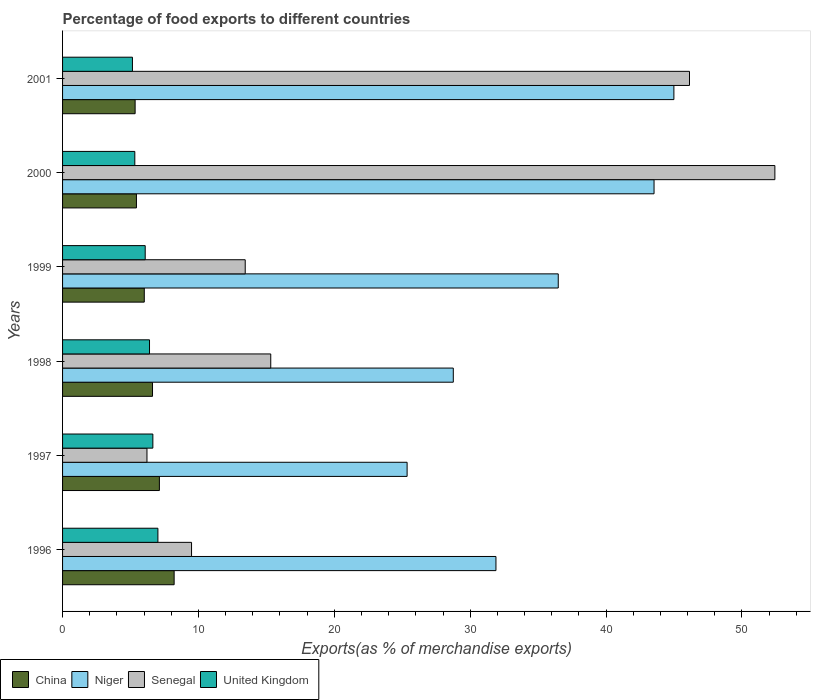How many groups of bars are there?
Provide a short and direct response. 6. Are the number of bars per tick equal to the number of legend labels?
Offer a terse response. Yes. Are the number of bars on each tick of the Y-axis equal?
Your response must be concise. Yes. What is the label of the 5th group of bars from the top?
Provide a short and direct response. 1997. In how many cases, is the number of bars for a given year not equal to the number of legend labels?
Offer a terse response. 0. What is the percentage of exports to different countries in Senegal in 1997?
Keep it short and to the point. 6.21. Across all years, what is the maximum percentage of exports to different countries in China?
Make the answer very short. 8.21. Across all years, what is the minimum percentage of exports to different countries in China?
Ensure brevity in your answer.  5.34. In which year was the percentage of exports to different countries in China minimum?
Your answer should be very brief. 2001. What is the total percentage of exports to different countries in Niger in the graph?
Keep it short and to the point. 211.01. What is the difference between the percentage of exports to different countries in United Kingdom in 1999 and that in 2001?
Ensure brevity in your answer.  0.94. What is the difference between the percentage of exports to different countries in China in 1998 and the percentage of exports to different countries in United Kingdom in 1999?
Your answer should be very brief. 0.54. What is the average percentage of exports to different countries in China per year?
Your response must be concise. 6.46. In the year 1998, what is the difference between the percentage of exports to different countries in Senegal and percentage of exports to different countries in Niger?
Ensure brevity in your answer.  -13.44. In how many years, is the percentage of exports to different countries in Niger greater than 22 %?
Your response must be concise. 6. What is the ratio of the percentage of exports to different countries in Niger in 1998 to that in 2001?
Offer a terse response. 0.64. Is the difference between the percentage of exports to different countries in Senegal in 1998 and 1999 greater than the difference between the percentage of exports to different countries in Niger in 1998 and 1999?
Ensure brevity in your answer.  Yes. What is the difference between the highest and the second highest percentage of exports to different countries in Senegal?
Keep it short and to the point. 6.28. What is the difference between the highest and the lowest percentage of exports to different countries in Senegal?
Provide a succinct answer. 46.21. Is the sum of the percentage of exports to different countries in China in 1996 and 1998 greater than the maximum percentage of exports to different countries in Niger across all years?
Offer a very short reply. No. What does the 3rd bar from the top in 2000 represents?
Offer a very short reply. Niger. Is it the case that in every year, the sum of the percentage of exports to different countries in China and percentage of exports to different countries in Niger is greater than the percentage of exports to different countries in Senegal?
Your answer should be compact. No. How many bars are there?
Provide a short and direct response. 24. How many years are there in the graph?
Give a very brief answer. 6. What is the difference between two consecutive major ticks on the X-axis?
Give a very brief answer. 10. Does the graph contain grids?
Your response must be concise. No. Where does the legend appear in the graph?
Your answer should be compact. Bottom left. How are the legend labels stacked?
Ensure brevity in your answer.  Horizontal. What is the title of the graph?
Your answer should be very brief. Percentage of food exports to different countries. Does "High income: OECD" appear as one of the legend labels in the graph?
Your response must be concise. No. What is the label or title of the X-axis?
Ensure brevity in your answer.  Exports(as % of merchandise exports). What is the label or title of the Y-axis?
Provide a short and direct response. Years. What is the Exports(as % of merchandise exports) of China in 1996?
Ensure brevity in your answer.  8.21. What is the Exports(as % of merchandise exports) in Niger in 1996?
Your answer should be very brief. 31.9. What is the Exports(as % of merchandise exports) of Senegal in 1996?
Offer a terse response. 9.49. What is the Exports(as % of merchandise exports) of United Kingdom in 1996?
Keep it short and to the point. 7.02. What is the Exports(as % of merchandise exports) in China in 1997?
Keep it short and to the point. 7.13. What is the Exports(as % of merchandise exports) of Niger in 1997?
Your answer should be very brief. 25.36. What is the Exports(as % of merchandise exports) in Senegal in 1997?
Offer a very short reply. 6.21. What is the Exports(as % of merchandise exports) of United Kingdom in 1997?
Give a very brief answer. 6.64. What is the Exports(as % of merchandise exports) in China in 1998?
Offer a very short reply. 6.62. What is the Exports(as % of merchandise exports) in Niger in 1998?
Your response must be concise. 28.76. What is the Exports(as % of merchandise exports) in Senegal in 1998?
Your answer should be compact. 15.32. What is the Exports(as % of merchandise exports) in United Kingdom in 1998?
Ensure brevity in your answer.  6.4. What is the Exports(as % of merchandise exports) in China in 1999?
Make the answer very short. 6.01. What is the Exports(as % of merchandise exports) of Niger in 1999?
Ensure brevity in your answer.  36.48. What is the Exports(as % of merchandise exports) in Senegal in 1999?
Keep it short and to the point. 13.44. What is the Exports(as % of merchandise exports) of United Kingdom in 1999?
Offer a terse response. 6.08. What is the Exports(as % of merchandise exports) of China in 2000?
Ensure brevity in your answer.  5.44. What is the Exports(as % of merchandise exports) in Niger in 2000?
Keep it short and to the point. 43.53. What is the Exports(as % of merchandise exports) in Senegal in 2000?
Make the answer very short. 52.42. What is the Exports(as % of merchandise exports) in United Kingdom in 2000?
Your answer should be very brief. 5.32. What is the Exports(as % of merchandise exports) of China in 2001?
Keep it short and to the point. 5.34. What is the Exports(as % of merchandise exports) in Niger in 2001?
Make the answer very short. 44.99. What is the Exports(as % of merchandise exports) of Senegal in 2001?
Your answer should be compact. 46.14. What is the Exports(as % of merchandise exports) of United Kingdom in 2001?
Make the answer very short. 5.14. Across all years, what is the maximum Exports(as % of merchandise exports) in China?
Your response must be concise. 8.21. Across all years, what is the maximum Exports(as % of merchandise exports) in Niger?
Offer a terse response. 44.99. Across all years, what is the maximum Exports(as % of merchandise exports) of Senegal?
Offer a terse response. 52.42. Across all years, what is the maximum Exports(as % of merchandise exports) in United Kingdom?
Your answer should be very brief. 7.02. Across all years, what is the minimum Exports(as % of merchandise exports) of China?
Ensure brevity in your answer.  5.34. Across all years, what is the minimum Exports(as % of merchandise exports) in Niger?
Your response must be concise. 25.36. Across all years, what is the minimum Exports(as % of merchandise exports) of Senegal?
Offer a terse response. 6.21. Across all years, what is the minimum Exports(as % of merchandise exports) of United Kingdom?
Make the answer very short. 5.14. What is the total Exports(as % of merchandise exports) in China in the graph?
Your answer should be compact. 38.75. What is the total Exports(as % of merchandise exports) in Niger in the graph?
Provide a succinct answer. 211.01. What is the total Exports(as % of merchandise exports) in Senegal in the graph?
Your answer should be compact. 143.03. What is the total Exports(as % of merchandise exports) of United Kingdom in the graph?
Your response must be concise. 36.6. What is the difference between the Exports(as % of merchandise exports) in China in 1996 and that in 1997?
Your response must be concise. 1.09. What is the difference between the Exports(as % of merchandise exports) of Niger in 1996 and that in 1997?
Provide a short and direct response. 6.54. What is the difference between the Exports(as % of merchandise exports) in Senegal in 1996 and that in 1997?
Provide a short and direct response. 3.28. What is the difference between the Exports(as % of merchandise exports) of United Kingdom in 1996 and that in 1997?
Ensure brevity in your answer.  0.37. What is the difference between the Exports(as % of merchandise exports) of China in 1996 and that in 1998?
Keep it short and to the point. 1.59. What is the difference between the Exports(as % of merchandise exports) of Niger in 1996 and that in 1998?
Provide a short and direct response. 3.14. What is the difference between the Exports(as % of merchandise exports) of Senegal in 1996 and that in 1998?
Provide a short and direct response. -5.83. What is the difference between the Exports(as % of merchandise exports) of United Kingdom in 1996 and that in 1998?
Your answer should be compact. 0.62. What is the difference between the Exports(as % of merchandise exports) in China in 1996 and that in 1999?
Your response must be concise. 2.2. What is the difference between the Exports(as % of merchandise exports) of Niger in 1996 and that in 1999?
Make the answer very short. -4.59. What is the difference between the Exports(as % of merchandise exports) in Senegal in 1996 and that in 1999?
Your response must be concise. -3.95. What is the difference between the Exports(as % of merchandise exports) in United Kingdom in 1996 and that in 1999?
Provide a short and direct response. 0.93. What is the difference between the Exports(as % of merchandise exports) of China in 1996 and that in 2000?
Your response must be concise. 2.77. What is the difference between the Exports(as % of merchandise exports) in Niger in 1996 and that in 2000?
Offer a terse response. -11.63. What is the difference between the Exports(as % of merchandise exports) of Senegal in 1996 and that in 2000?
Offer a very short reply. -42.93. What is the difference between the Exports(as % of merchandise exports) in United Kingdom in 1996 and that in 2000?
Your answer should be compact. 1.7. What is the difference between the Exports(as % of merchandise exports) in China in 1996 and that in 2001?
Make the answer very short. 2.87. What is the difference between the Exports(as % of merchandise exports) of Niger in 1996 and that in 2001?
Keep it short and to the point. -13.1. What is the difference between the Exports(as % of merchandise exports) in Senegal in 1996 and that in 2001?
Offer a very short reply. -36.65. What is the difference between the Exports(as % of merchandise exports) of United Kingdom in 1996 and that in 2001?
Provide a short and direct response. 1.87. What is the difference between the Exports(as % of merchandise exports) of China in 1997 and that in 1998?
Keep it short and to the point. 0.51. What is the difference between the Exports(as % of merchandise exports) in Niger in 1997 and that in 1998?
Provide a short and direct response. -3.4. What is the difference between the Exports(as % of merchandise exports) in Senegal in 1997 and that in 1998?
Your answer should be compact. -9.11. What is the difference between the Exports(as % of merchandise exports) of United Kingdom in 1997 and that in 1998?
Give a very brief answer. 0.25. What is the difference between the Exports(as % of merchandise exports) in China in 1997 and that in 1999?
Ensure brevity in your answer.  1.11. What is the difference between the Exports(as % of merchandise exports) in Niger in 1997 and that in 1999?
Provide a succinct answer. -11.12. What is the difference between the Exports(as % of merchandise exports) in Senegal in 1997 and that in 1999?
Your answer should be compact. -7.23. What is the difference between the Exports(as % of merchandise exports) in United Kingdom in 1997 and that in 1999?
Give a very brief answer. 0.56. What is the difference between the Exports(as % of merchandise exports) of China in 1997 and that in 2000?
Your answer should be compact. 1.69. What is the difference between the Exports(as % of merchandise exports) in Niger in 1997 and that in 2000?
Your response must be concise. -18.17. What is the difference between the Exports(as % of merchandise exports) in Senegal in 1997 and that in 2000?
Provide a short and direct response. -46.21. What is the difference between the Exports(as % of merchandise exports) of United Kingdom in 1997 and that in 2000?
Provide a short and direct response. 1.33. What is the difference between the Exports(as % of merchandise exports) of China in 1997 and that in 2001?
Your answer should be very brief. 1.79. What is the difference between the Exports(as % of merchandise exports) in Niger in 1997 and that in 2001?
Keep it short and to the point. -19.63. What is the difference between the Exports(as % of merchandise exports) of Senegal in 1997 and that in 2001?
Your answer should be compact. -39.93. What is the difference between the Exports(as % of merchandise exports) in United Kingdom in 1997 and that in 2001?
Provide a short and direct response. 1.5. What is the difference between the Exports(as % of merchandise exports) in China in 1998 and that in 1999?
Offer a terse response. 0.61. What is the difference between the Exports(as % of merchandise exports) of Niger in 1998 and that in 1999?
Provide a succinct answer. -7.72. What is the difference between the Exports(as % of merchandise exports) of Senegal in 1998 and that in 1999?
Your answer should be very brief. 1.88. What is the difference between the Exports(as % of merchandise exports) in United Kingdom in 1998 and that in 1999?
Offer a very short reply. 0.32. What is the difference between the Exports(as % of merchandise exports) of China in 1998 and that in 2000?
Ensure brevity in your answer.  1.18. What is the difference between the Exports(as % of merchandise exports) in Niger in 1998 and that in 2000?
Your answer should be very brief. -14.77. What is the difference between the Exports(as % of merchandise exports) in Senegal in 1998 and that in 2000?
Make the answer very short. -37.1. What is the difference between the Exports(as % of merchandise exports) in United Kingdom in 1998 and that in 2000?
Your answer should be compact. 1.08. What is the difference between the Exports(as % of merchandise exports) in China in 1998 and that in 2001?
Provide a succinct answer. 1.28. What is the difference between the Exports(as % of merchandise exports) in Niger in 1998 and that in 2001?
Your response must be concise. -16.24. What is the difference between the Exports(as % of merchandise exports) of Senegal in 1998 and that in 2001?
Your response must be concise. -30.82. What is the difference between the Exports(as % of merchandise exports) of United Kingdom in 1998 and that in 2001?
Your answer should be compact. 1.26. What is the difference between the Exports(as % of merchandise exports) of China in 1999 and that in 2000?
Offer a very short reply. 0.58. What is the difference between the Exports(as % of merchandise exports) of Niger in 1999 and that in 2000?
Keep it short and to the point. -7.05. What is the difference between the Exports(as % of merchandise exports) in Senegal in 1999 and that in 2000?
Keep it short and to the point. -38.98. What is the difference between the Exports(as % of merchandise exports) in United Kingdom in 1999 and that in 2000?
Ensure brevity in your answer.  0.77. What is the difference between the Exports(as % of merchandise exports) in China in 1999 and that in 2001?
Provide a succinct answer. 0.67. What is the difference between the Exports(as % of merchandise exports) in Niger in 1999 and that in 2001?
Offer a very short reply. -8.51. What is the difference between the Exports(as % of merchandise exports) of Senegal in 1999 and that in 2001?
Provide a succinct answer. -32.7. What is the difference between the Exports(as % of merchandise exports) of United Kingdom in 1999 and that in 2001?
Keep it short and to the point. 0.94. What is the difference between the Exports(as % of merchandise exports) of China in 2000 and that in 2001?
Give a very brief answer. 0.1. What is the difference between the Exports(as % of merchandise exports) of Niger in 2000 and that in 2001?
Provide a succinct answer. -1.46. What is the difference between the Exports(as % of merchandise exports) of Senegal in 2000 and that in 2001?
Make the answer very short. 6.28. What is the difference between the Exports(as % of merchandise exports) of United Kingdom in 2000 and that in 2001?
Keep it short and to the point. 0.17. What is the difference between the Exports(as % of merchandise exports) in China in 1996 and the Exports(as % of merchandise exports) in Niger in 1997?
Your answer should be very brief. -17.15. What is the difference between the Exports(as % of merchandise exports) in China in 1996 and the Exports(as % of merchandise exports) in Senegal in 1997?
Your response must be concise. 2. What is the difference between the Exports(as % of merchandise exports) of China in 1996 and the Exports(as % of merchandise exports) of United Kingdom in 1997?
Offer a very short reply. 1.57. What is the difference between the Exports(as % of merchandise exports) of Niger in 1996 and the Exports(as % of merchandise exports) of Senegal in 1997?
Ensure brevity in your answer.  25.68. What is the difference between the Exports(as % of merchandise exports) of Niger in 1996 and the Exports(as % of merchandise exports) of United Kingdom in 1997?
Make the answer very short. 25.25. What is the difference between the Exports(as % of merchandise exports) in Senegal in 1996 and the Exports(as % of merchandise exports) in United Kingdom in 1997?
Give a very brief answer. 2.85. What is the difference between the Exports(as % of merchandise exports) of China in 1996 and the Exports(as % of merchandise exports) of Niger in 1998?
Your response must be concise. -20.55. What is the difference between the Exports(as % of merchandise exports) in China in 1996 and the Exports(as % of merchandise exports) in Senegal in 1998?
Keep it short and to the point. -7.11. What is the difference between the Exports(as % of merchandise exports) in China in 1996 and the Exports(as % of merchandise exports) in United Kingdom in 1998?
Your answer should be very brief. 1.81. What is the difference between the Exports(as % of merchandise exports) of Niger in 1996 and the Exports(as % of merchandise exports) of Senegal in 1998?
Provide a succinct answer. 16.57. What is the difference between the Exports(as % of merchandise exports) of Niger in 1996 and the Exports(as % of merchandise exports) of United Kingdom in 1998?
Offer a terse response. 25.5. What is the difference between the Exports(as % of merchandise exports) of Senegal in 1996 and the Exports(as % of merchandise exports) of United Kingdom in 1998?
Your response must be concise. 3.09. What is the difference between the Exports(as % of merchandise exports) of China in 1996 and the Exports(as % of merchandise exports) of Niger in 1999?
Provide a short and direct response. -28.27. What is the difference between the Exports(as % of merchandise exports) in China in 1996 and the Exports(as % of merchandise exports) in Senegal in 1999?
Give a very brief answer. -5.23. What is the difference between the Exports(as % of merchandise exports) of China in 1996 and the Exports(as % of merchandise exports) of United Kingdom in 1999?
Offer a very short reply. 2.13. What is the difference between the Exports(as % of merchandise exports) in Niger in 1996 and the Exports(as % of merchandise exports) in Senegal in 1999?
Offer a terse response. 18.45. What is the difference between the Exports(as % of merchandise exports) of Niger in 1996 and the Exports(as % of merchandise exports) of United Kingdom in 1999?
Provide a succinct answer. 25.81. What is the difference between the Exports(as % of merchandise exports) in Senegal in 1996 and the Exports(as % of merchandise exports) in United Kingdom in 1999?
Your response must be concise. 3.41. What is the difference between the Exports(as % of merchandise exports) in China in 1996 and the Exports(as % of merchandise exports) in Niger in 2000?
Give a very brief answer. -35.32. What is the difference between the Exports(as % of merchandise exports) of China in 1996 and the Exports(as % of merchandise exports) of Senegal in 2000?
Your answer should be very brief. -44.21. What is the difference between the Exports(as % of merchandise exports) in China in 1996 and the Exports(as % of merchandise exports) in United Kingdom in 2000?
Your answer should be very brief. 2.89. What is the difference between the Exports(as % of merchandise exports) in Niger in 1996 and the Exports(as % of merchandise exports) in Senegal in 2000?
Your response must be concise. -20.53. What is the difference between the Exports(as % of merchandise exports) of Niger in 1996 and the Exports(as % of merchandise exports) of United Kingdom in 2000?
Give a very brief answer. 26.58. What is the difference between the Exports(as % of merchandise exports) in Senegal in 1996 and the Exports(as % of merchandise exports) in United Kingdom in 2000?
Ensure brevity in your answer.  4.18. What is the difference between the Exports(as % of merchandise exports) of China in 1996 and the Exports(as % of merchandise exports) of Niger in 2001?
Give a very brief answer. -36.78. What is the difference between the Exports(as % of merchandise exports) in China in 1996 and the Exports(as % of merchandise exports) in Senegal in 2001?
Your answer should be compact. -37.93. What is the difference between the Exports(as % of merchandise exports) in China in 1996 and the Exports(as % of merchandise exports) in United Kingdom in 2001?
Give a very brief answer. 3.07. What is the difference between the Exports(as % of merchandise exports) in Niger in 1996 and the Exports(as % of merchandise exports) in Senegal in 2001?
Give a very brief answer. -14.24. What is the difference between the Exports(as % of merchandise exports) in Niger in 1996 and the Exports(as % of merchandise exports) in United Kingdom in 2001?
Offer a very short reply. 26.75. What is the difference between the Exports(as % of merchandise exports) in Senegal in 1996 and the Exports(as % of merchandise exports) in United Kingdom in 2001?
Make the answer very short. 4.35. What is the difference between the Exports(as % of merchandise exports) of China in 1997 and the Exports(as % of merchandise exports) of Niger in 1998?
Make the answer very short. -21.63. What is the difference between the Exports(as % of merchandise exports) of China in 1997 and the Exports(as % of merchandise exports) of Senegal in 1998?
Provide a succinct answer. -8.2. What is the difference between the Exports(as % of merchandise exports) in China in 1997 and the Exports(as % of merchandise exports) in United Kingdom in 1998?
Give a very brief answer. 0.73. What is the difference between the Exports(as % of merchandise exports) of Niger in 1997 and the Exports(as % of merchandise exports) of Senegal in 1998?
Offer a very short reply. 10.04. What is the difference between the Exports(as % of merchandise exports) of Niger in 1997 and the Exports(as % of merchandise exports) of United Kingdom in 1998?
Your response must be concise. 18.96. What is the difference between the Exports(as % of merchandise exports) in Senegal in 1997 and the Exports(as % of merchandise exports) in United Kingdom in 1998?
Give a very brief answer. -0.19. What is the difference between the Exports(as % of merchandise exports) in China in 1997 and the Exports(as % of merchandise exports) in Niger in 1999?
Give a very brief answer. -29.36. What is the difference between the Exports(as % of merchandise exports) in China in 1997 and the Exports(as % of merchandise exports) in Senegal in 1999?
Your response must be concise. -6.32. What is the difference between the Exports(as % of merchandise exports) of China in 1997 and the Exports(as % of merchandise exports) of United Kingdom in 1999?
Your answer should be compact. 1.04. What is the difference between the Exports(as % of merchandise exports) of Niger in 1997 and the Exports(as % of merchandise exports) of Senegal in 1999?
Your answer should be very brief. 11.91. What is the difference between the Exports(as % of merchandise exports) in Niger in 1997 and the Exports(as % of merchandise exports) in United Kingdom in 1999?
Your response must be concise. 19.28. What is the difference between the Exports(as % of merchandise exports) in Senegal in 1997 and the Exports(as % of merchandise exports) in United Kingdom in 1999?
Ensure brevity in your answer.  0.13. What is the difference between the Exports(as % of merchandise exports) in China in 1997 and the Exports(as % of merchandise exports) in Niger in 2000?
Keep it short and to the point. -36.4. What is the difference between the Exports(as % of merchandise exports) in China in 1997 and the Exports(as % of merchandise exports) in Senegal in 2000?
Ensure brevity in your answer.  -45.3. What is the difference between the Exports(as % of merchandise exports) of China in 1997 and the Exports(as % of merchandise exports) of United Kingdom in 2000?
Your answer should be very brief. 1.81. What is the difference between the Exports(as % of merchandise exports) in Niger in 1997 and the Exports(as % of merchandise exports) in Senegal in 2000?
Provide a short and direct response. -27.07. What is the difference between the Exports(as % of merchandise exports) in Niger in 1997 and the Exports(as % of merchandise exports) in United Kingdom in 2000?
Give a very brief answer. 20.04. What is the difference between the Exports(as % of merchandise exports) in Senegal in 1997 and the Exports(as % of merchandise exports) in United Kingdom in 2000?
Offer a terse response. 0.89. What is the difference between the Exports(as % of merchandise exports) of China in 1997 and the Exports(as % of merchandise exports) of Niger in 2001?
Give a very brief answer. -37.87. What is the difference between the Exports(as % of merchandise exports) in China in 1997 and the Exports(as % of merchandise exports) in Senegal in 2001?
Your response must be concise. -39.01. What is the difference between the Exports(as % of merchandise exports) of China in 1997 and the Exports(as % of merchandise exports) of United Kingdom in 2001?
Provide a succinct answer. 1.98. What is the difference between the Exports(as % of merchandise exports) of Niger in 1997 and the Exports(as % of merchandise exports) of Senegal in 2001?
Your answer should be very brief. -20.78. What is the difference between the Exports(as % of merchandise exports) of Niger in 1997 and the Exports(as % of merchandise exports) of United Kingdom in 2001?
Provide a succinct answer. 20.21. What is the difference between the Exports(as % of merchandise exports) in Senegal in 1997 and the Exports(as % of merchandise exports) in United Kingdom in 2001?
Make the answer very short. 1.07. What is the difference between the Exports(as % of merchandise exports) of China in 1998 and the Exports(as % of merchandise exports) of Niger in 1999?
Your response must be concise. -29.86. What is the difference between the Exports(as % of merchandise exports) of China in 1998 and the Exports(as % of merchandise exports) of Senegal in 1999?
Give a very brief answer. -6.82. What is the difference between the Exports(as % of merchandise exports) in China in 1998 and the Exports(as % of merchandise exports) in United Kingdom in 1999?
Provide a short and direct response. 0.54. What is the difference between the Exports(as % of merchandise exports) in Niger in 1998 and the Exports(as % of merchandise exports) in Senegal in 1999?
Keep it short and to the point. 15.31. What is the difference between the Exports(as % of merchandise exports) in Niger in 1998 and the Exports(as % of merchandise exports) in United Kingdom in 1999?
Your answer should be very brief. 22.67. What is the difference between the Exports(as % of merchandise exports) in Senegal in 1998 and the Exports(as % of merchandise exports) in United Kingdom in 1999?
Your answer should be very brief. 9.24. What is the difference between the Exports(as % of merchandise exports) in China in 1998 and the Exports(as % of merchandise exports) in Niger in 2000?
Your answer should be very brief. -36.91. What is the difference between the Exports(as % of merchandise exports) in China in 1998 and the Exports(as % of merchandise exports) in Senegal in 2000?
Provide a short and direct response. -45.8. What is the difference between the Exports(as % of merchandise exports) in China in 1998 and the Exports(as % of merchandise exports) in United Kingdom in 2000?
Give a very brief answer. 1.3. What is the difference between the Exports(as % of merchandise exports) of Niger in 1998 and the Exports(as % of merchandise exports) of Senegal in 2000?
Provide a short and direct response. -23.67. What is the difference between the Exports(as % of merchandise exports) in Niger in 1998 and the Exports(as % of merchandise exports) in United Kingdom in 2000?
Your response must be concise. 23.44. What is the difference between the Exports(as % of merchandise exports) in Senegal in 1998 and the Exports(as % of merchandise exports) in United Kingdom in 2000?
Ensure brevity in your answer.  10. What is the difference between the Exports(as % of merchandise exports) of China in 1998 and the Exports(as % of merchandise exports) of Niger in 2001?
Provide a short and direct response. -38.37. What is the difference between the Exports(as % of merchandise exports) of China in 1998 and the Exports(as % of merchandise exports) of Senegal in 2001?
Your answer should be compact. -39.52. What is the difference between the Exports(as % of merchandise exports) of China in 1998 and the Exports(as % of merchandise exports) of United Kingdom in 2001?
Your answer should be very brief. 1.48. What is the difference between the Exports(as % of merchandise exports) in Niger in 1998 and the Exports(as % of merchandise exports) in Senegal in 2001?
Offer a terse response. -17.38. What is the difference between the Exports(as % of merchandise exports) of Niger in 1998 and the Exports(as % of merchandise exports) of United Kingdom in 2001?
Your response must be concise. 23.61. What is the difference between the Exports(as % of merchandise exports) in Senegal in 1998 and the Exports(as % of merchandise exports) in United Kingdom in 2001?
Your answer should be very brief. 10.18. What is the difference between the Exports(as % of merchandise exports) of China in 1999 and the Exports(as % of merchandise exports) of Niger in 2000?
Your answer should be very brief. -37.52. What is the difference between the Exports(as % of merchandise exports) of China in 1999 and the Exports(as % of merchandise exports) of Senegal in 2000?
Make the answer very short. -46.41. What is the difference between the Exports(as % of merchandise exports) in China in 1999 and the Exports(as % of merchandise exports) in United Kingdom in 2000?
Offer a very short reply. 0.7. What is the difference between the Exports(as % of merchandise exports) in Niger in 1999 and the Exports(as % of merchandise exports) in Senegal in 2000?
Offer a terse response. -15.94. What is the difference between the Exports(as % of merchandise exports) in Niger in 1999 and the Exports(as % of merchandise exports) in United Kingdom in 2000?
Your answer should be very brief. 31.16. What is the difference between the Exports(as % of merchandise exports) in Senegal in 1999 and the Exports(as % of merchandise exports) in United Kingdom in 2000?
Provide a short and direct response. 8.13. What is the difference between the Exports(as % of merchandise exports) in China in 1999 and the Exports(as % of merchandise exports) in Niger in 2001?
Your response must be concise. -38.98. What is the difference between the Exports(as % of merchandise exports) in China in 1999 and the Exports(as % of merchandise exports) in Senegal in 2001?
Your answer should be compact. -40.13. What is the difference between the Exports(as % of merchandise exports) in China in 1999 and the Exports(as % of merchandise exports) in United Kingdom in 2001?
Give a very brief answer. 0.87. What is the difference between the Exports(as % of merchandise exports) in Niger in 1999 and the Exports(as % of merchandise exports) in Senegal in 2001?
Provide a succinct answer. -9.66. What is the difference between the Exports(as % of merchandise exports) of Niger in 1999 and the Exports(as % of merchandise exports) of United Kingdom in 2001?
Offer a terse response. 31.34. What is the difference between the Exports(as % of merchandise exports) in Senegal in 1999 and the Exports(as % of merchandise exports) in United Kingdom in 2001?
Make the answer very short. 8.3. What is the difference between the Exports(as % of merchandise exports) in China in 2000 and the Exports(as % of merchandise exports) in Niger in 2001?
Give a very brief answer. -39.55. What is the difference between the Exports(as % of merchandise exports) in China in 2000 and the Exports(as % of merchandise exports) in Senegal in 2001?
Provide a succinct answer. -40.7. What is the difference between the Exports(as % of merchandise exports) in China in 2000 and the Exports(as % of merchandise exports) in United Kingdom in 2001?
Provide a short and direct response. 0.29. What is the difference between the Exports(as % of merchandise exports) of Niger in 2000 and the Exports(as % of merchandise exports) of Senegal in 2001?
Give a very brief answer. -2.61. What is the difference between the Exports(as % of merchandise exports) of Niger in 2000 and the Exports(as % of merchandise exports) of United Kingdom in 2001?
Your answer should be very brief. 38.39. What is the difference between the Exports(as % of merchandise exports) of Senegal in 2000 and the Exports(as % of merchandise exports) of United Kingdom in 2001?
Provide a succinct answer. 47.28. What is the average Exports(as % of merchandise exports) of China per year?
Offer a very short reply. 6.46. What is the average Exports(as % of merchandise exports) of Niger per year?
Offer a terse response. 35.17. What is the average Exports(as % of merchandise exports) in Senegal per year?
Give a very brief answer. 23.84. What is the average Exports(as % of merchandise exports) in United Kingdom per year?
Give a very brief answer. 6.1. In the year 1996, what is the difference between the Exports(as % of merchandise exports) in China and Exports(as % of merchandise exports) in Niger?
Your answer should be compact. -23.68. In the year 1996, what is the difference between the Exports(as % of merchandise exports) in China and Exports(as % of merchandise exports) in Senegal?
Give a very brief answer. -1.28. In the year 1996, what is the difference between the Exports(as % of merchandise exports) of China and Exports(as % of merchandise exports) of United Kingdom?
Your response must be concise. 1.2. In the year 1996, what is the difference between the Exports(as % of merchandise exports) in Niger and Exports(as % of merchandise exports) in Senegal?
Ensure brevity in your answer.  22.4. In the year 1996, what is the difference between the Exports(as % of merchandise exports) in Niger and Exports(as % of merchandise exports) in United Kingdom?
Keep it short and to the point. 24.88. In the year 1996, what is the difference between the Exports(as % of merchandise exports) in Senegal and Exports(as % of merchandise exports) in United Kingdom?
Keep it short and to the point. 2.48. In the year 1997, what is the difference between the Exports(as % of merchandise exports) in China and Exports(as % of merchandise exports) in Niger?
Your answer should be compact. -18.23. In the year 1997, what is the difference between the Exports(as % of merchandise exports) in China and Exports(as % of merchandise exports) in Senegal?
Give a very brief answer. 0.91. In the year 1997, what is the difference between the Exports(as % of merchandise exports) of China and Exports(as % of merchandise exports) of United Kingdom?
Provide a succinct answer. 0.48. In the year 1997, what is the difference between the Exports(as % of merchandise exports) of Niger and Exports(as % of merchandise exports) of Senegal?
Provide a succinct answer. 19.15. In the year 1997, what is the difference between the Exports(as % of merchandise exports) of Niger and Exports(as % of merchandise exports) of United Kingdom?
Provide a succinct answer. 18.71. In the year 1997, what is the difference between the Exports(as % of merchandise exports) of Senegal and Exports(as % of merchandise exports) of United Kingdom?
Give a very brief answer. -0.43. In the year 1998, what is the difference between the Exports(as % of merchandise exports) in China and Exports(as % of merchandise exports) in Niger?
Give a very brief answer. -22.14. In the year 1998, what is the difference between the Exports(as % of merchandise exports) in China and Exports(as % of merchandise exports) in Senegal?
Your response must be concise. -8.7. In the year 1998, what is the difference between the Exports(as % of merchandise exports) of China and Exports(as % of merchandise exports) of United Kingdom?
Make the answer very short. 0.22. In the year 1998, what is the difference between the Exports(as % of merchandise exports) in Niger and Exports(as % of merchandise exports) in Senegal?
Your answer should be compact. 13.44. In the year 1998, what is the difference between the Exports(as % of merchandise exports) in Niger and Exports(as % of merchandise exports) in United Kingdom?
Offer a terse response. 22.36. In the year 1998, what is the difference between the Exports(as % of merchandise exports) of Senegal and Exports(as % of merchandise exports) of United Kingdom?
Ensure brevity in your answer.  8.92. In the year 1999, what is the difference between the Exports(as % of merchandise exports) in China and Exports(as % of merchandise exports) in Niger?
Make the answer very short. -30.47. In the year 1999, what is the difference between the Exports(as % of merchandise exports) of China and Exports(as % of merchandise exports) of Senegal?
Offer a terse response. -7.43. In the year 1999, what is the difference between the Exports(as % of merchandise exports) in China and Exports(as % of merchandise exports) in United Kingdom?
Make the answer very short. -0.07. In the year 1999, what is the difference between the Exports(as % of merchandise exports) of Niger and Exports(as % of merchandise exports) of Senegal?
Give a very brief answer. 23.04. In the year 1999, what is the difference between the Exports(as % of merchandise exports) in Niger and Exports(as % of merchandise exports) in United Kingdom?
Your response must be concise. 30.4. In the year 1999, what is the difference between the Exports(as % of merchandise exports) in Senegal and Exports(as % of merchandise exports) in United Kingdom?
Give a very brief answer. 7.36. In the year 2000, what is the difference between the Exports(as % of merchandise exports) of China and Exports(as % of merchandise exports) of Niger?
Ensure brevity in your answer.  -38.09. In the year 2000, what is the difference between the Exports(as % of merchandise exports) of China and Exports(as % of merchandise exports) of Senegal?
Your response must be concise. -46.99. In the year 2000, what is the difference between the Exports(as % of merchandise exports) of China and Exports(as % of merchandise exports) of United Kingdom?
Keep it short and to the point. 0.12. In the year 2000, what is the difference between the Exports(as % of merchandise exports) in Niger and Exports(as % of merchandise exports) in Senegal?
Your answer should be compact. -8.89. In the year 2000, what is the difference between the Exports(as % of merchandise exports) in Niger and Exports(as % of merchandise exports) in United Kingdom?
Your answer should be compact. 38.21. In the year 2000, what is the difference between the Exports(as % of merchandise exports) of Senegal and Exports(as % of merchandise exports) of United Kingdom?
Make the answer very short. 47.11. In the year 2001, what is the difference between the Exports(as % of merchandise exports) of China and Exports(as % of merchandise exports) of Niger?
Keep it short and to the point. -39.65. In the year 2001, what is the difference between the Exports(as % of merchandise exports) in China and Exports(as % of merchandise exports) in Senegal?
Your answer should be compact. -40.8. In the year 2001, what is the difference between the Exports(as % of merchandise exports) of China and Exports(as % of merchandise exports) of United Kingdom?
Offer a terse response. 0.2. In the year 2001, what is the difference between the Exports(as % of merchandise exports) of Niger and Exports(as % of merchandise exports) of Senegal?
Ensure brevity in your answer.  -1.15. In the year 2001, what is the difference between the Exports(as % of merchandise exports) in Niger and Exports(as % of merchandise exports) in United Kingdom?
Give a very brief answer. 39.85. In the year 2001, what is the difference between the Exports(as % of merchandise exports) of Senegal and Exports(as % of merchandise exports) of United Kingdom?
Offer a terse response. 41. What is the ratio of the Exports(as % of merchandise exports) in China in 1996 to that in 1997?
Your answer should be very brief. 1.15. What is the ratio of the Exports(as % of merchandise exports) in Niger in 1996 to that in 1997?
Provide a short and direct response. 1.26. What is the ratio of the Exports(as % of merchandise exports) of Senegal in 1996 to that in 1997?
Keep it short and to the point. 1.53. What is the ratio of the Exports(as % of merchandise exports) in United Kingdom in 1996 to that in 1997?
Ensure brevity in your answer.  1.06. What is the ratio of the Exports(as % of merchandise exports) of China in 1996 to that in 1998?
Your answer should be very brief. 1.24. What is the ratio of the Exports(as % of merchandise exports) in Niger in 1996 to that in 1998?
Offer a very short reply. 1.11. What is the ratio of the Exports(as % of merchandise exports) in Senegal in 1996 to that in 1998?
Provide a succinct answer. 0.62. What is the ratio of the Exports(as % of merchandise exports) in United Kingdom in 1996 to that in 1998?
Give a very brief answer. 1.1. What is the ratio of the Exports(as % of merchandise exports) in China in 1996 to that in 1999?
Your response must be concise. 1.37. What is the ratio of the Exports(as % of merchandise exports) in Niger in 1996 to that in 1999?
Make the answer very short. 0.87. What is the ratio of the Exports(as % of merchandise exports) of Senegal in 1996 to that in 1999?
Provide a short and direct response. 0.71. What is the ratio of the Exports(as % of merchandise exports) in United Kingdom in 1996 to that in 1999?
Offer a terse response. 1.15. What is the ratio of the Exports(as % of merchandise exports) in China in 1996 to that in 2000?
Your answer should be very brief. 1.51. What is the ratio of the Exports(as % of merchandise exports) of Niger in 1996 to that in 2000?
Offer a terse response. 0.73. What is the ratio of the Exports(as % of merchandise exports) of Senegal in 1996 to that in 2000?
Your response must be concise. 0.18. What is the ratio of the Exports(as % of merchandise exports) in United Kingdom in 1996 to that in 2000?
Give a very brief answer. 1.32. What is the ratio of the Exports(as % of merchandise exports) in China in 1996 to that in 2001?
Your response must be concise. 1.54. What is the ratio of the Exports(as % of merchandise exports) in Niger in 1996 to that in 2001?
Ensure brevity in your answer.  0.71. What is the ratio of the Exports(as % of merchandise exports) of Senegal in 1996 to that in 2001?
Keep it short and to the point. 0.21. What is the ratio of the Exports(as % of merchandise exports) of United Kingdom in 1996 to that in 2001?
Your answer should be compact. 1.36. What is the ratio of the Exports(as % of merchandise exports) of China in 1997 to that in 1998?
Keep it short and to the point. 1.08. What is the ratio of the Exports(as % of merchandise exports) in Niger in 1997 to that in 1998?
Your answer should be compact. 0.88. What is the ratio of the Exports(as % of merchandise exports) of Senegal in 1997 to that in 1998?
Your answer should be compact. 0.41. What is the ratio of the Exports(as % of merchandise exports) in United Kingdom in 1997 to that in 1998?
Your answer should be very brief. 1.04. What is the ratio of the Exports(as % of merchandise exports) in China in 1997 to that in 1999?
Keep it short and to the point. 1.19. What is the ratio of the Exports(as % of merchandise exports) of Niger in 1997 to that in 1999?
Provide a succinct answer. 0.7. What is the ratio of the Exports(as % of merchandise exports) in Senegal in 1997 to that in 1999?
Provide a short and direct response. 0.46. What is the ratio of the Exports(as % of merchandise exports) of United Kingdom in 1997 to that in 1999?
Offer a terse response. 1.09. What is the ratio of the Exports(as % of merchandise exports) in China in 1997 to that in 2000?
Your answer should be compact. 1.31. What is the ratio of the Exports(as % of merchandise exports) of Niger in 1997 to that in 2000?
Offer a terse response. 0.58. What is the ratio of the Exports(as % of merchandise exports) of Senegal in 1997 to that in 2000?
Your answer should be compact. 0.12. What is the ratio of the Exports(as % of merchandise exports) of United Kingdom in 1997 to that in 2000?
Provide a succinct answer. 1.25. What is the ratio of the Exports(as % of merchandise exports) of China in 1997 to that in 2001?
Keep it short and to the point. 1.33. What is the ratio of the Exports(as % of merchandise exports) in Niger in 1997 to that in 2001?
Give a very brief answer. 0.56. What is the ratio of the Exports(as % of merchandise exports) of Senegal in 1997 to that in 2001?
Provide a short and direct response. 0.13. What is the ratio of the Exports(as % of merchandise exports) in United Kingdom in 1997 to that in 2001?
Provide a succinct answer. 1.29. What is the ratio of the Exports(as % of merchandise exports) of China in 1998 to that in 1999?
Your response must be concise. 1.1. What is the ratio of the Exports(as % of merchandise exports) of Niger in 1998 to that in 1999?
Provide a short and direct response. 0.79. What is the ratio of the Exports(as % of merchandise exports) of Senegal in 1998 to that in 1999?
Your response must be concise. 1.14. What is the ratio of the Exports(as % of merchandise exports) in United Kingdom in 1998 to that in 1999?
Make the answer very short. 1.05. What is the ratio of the Exports(as % of merchandise exports) in China in 1998 to that in 2000?
Provide a succinct answer. 1.22. What is the ratio of the Exports(as % of merchandise exports) in Niger in 1998 to that in 2000?
Make the answer very short. 0.66. What is the ratio of the Exports(as % of merchandise exports) of Senegal in 1998 to that in 2000?
Ensure brevity in your answer.  0.29. What is the ratio of the Exports(as % of merchandise exports) in United Kingdom in 1998 to that in 2000?
Provide a succinct answer. 1.2. What is the ratio of the Exports(as % of merchandise exports) in China in 1998 to that in 2001?
Your answer should be compact. 1.24. What is the ratio of the Exports(as % of merchandise exports) of Niger in 1998 to that in 2001?
Your response must be concise. 0.64. What is the ratio of the Exports(as % of merchandise exports) in Senegal in 1998 to that in 2001?
Make the answer very short. 0.33. What is the ratio of the Exports(as % of merchandise exports) in United Kingdom in 1998 to that in 2001?
Make the answer very short. 1.24. What is the ratio of the Exports(as % of merchandise exports) of China in 1999 to that in 2000?
Keep it short and to the point. 1.11. What is the ratio of the Exports(as % of merchandise exports) of Niger in 1999 to that in 2000?
Provide a short and direct response. 0.84. What is the ratio of the Exports(as % of merchandise exports) of Senegal in 1999 to that in 2000?
Ensure brevity in your answer.  0.26. What is the ratio of the Exports(as % of merchandise exports) of United Kingdom in 1999 to that in 2000?
Your response must be concise. 1.14. What is the ratio of the Exports(as % of merchandise exports) in China in 1999 to that in 2001?
Provide a succinct answer. 1.13. What is the ratio of the Exports(as % of merchandise exports) in Niger in 1999 to that in 2001?
Ensure brevity in your answer.  0.81. What is the ratio of the Exports(as % of merchandise exports) of Senegal in 1999 to that in 2001?
Offer a terse response. 0.29. What is the ratio of the Exports(as % of merchandise exports) of United Kingdom in 1999 to that in 2001?
Your answer should be very brief. 1.18. What is the ratio of the Exports(as % of merchandise exports) in China in 2000 to that in 2001?
Provide a short and direct response. 1.02. What is the ratio of the Exports(as % of merchandise exports) in Niger in 2000 to that in 2001?
Offer a very short reply. 0.97. What is the ratio of the Exports(as % of merchandise exports) of Senegal in 2000 to that in 2001?
Ensure brevity in your answer.  1.14. What is the ratio of the Exports(as % of merchandise exports) of United Kingdom in 2000 to that in 2001?
Provide a short and direct response. 1.03. What is the difference between the highest and the second highest Exports(as % of merchandise exports) of China?
Provide a short and direct response. 1.09. What is the difference between the highest and the second highest Exports(as % of merchandise exports) in Niger?
Your answer should be very brief. 1.46. What is the difference between the highest and the second highest Exports(as % of merchandise exports) of Senegal?
Offer a terse response. 6.28. What is the difference between the highest and the second highest Exports(as % of merchandise exports) of United Kingdom?
Offer a terse response. 0.37. What is the difference between the highest and the lowest Exports(as % of merchandise exports) in China?
Keep it short and to the point. 2.87. What is the difference between the highest and the lowest Exports(as % of merchandise exports) in Niger?
Your response must be concise. 19.63. What is the difference between the highest and the lowest Exports(as % of merchandise exports) of Senegal?
Your answer should be compact. 46.21. What is the difference between the highest and the lowest Exports(as % of merchandise exports) in United Kingdom?
Your answer should be compact. 1.87. 